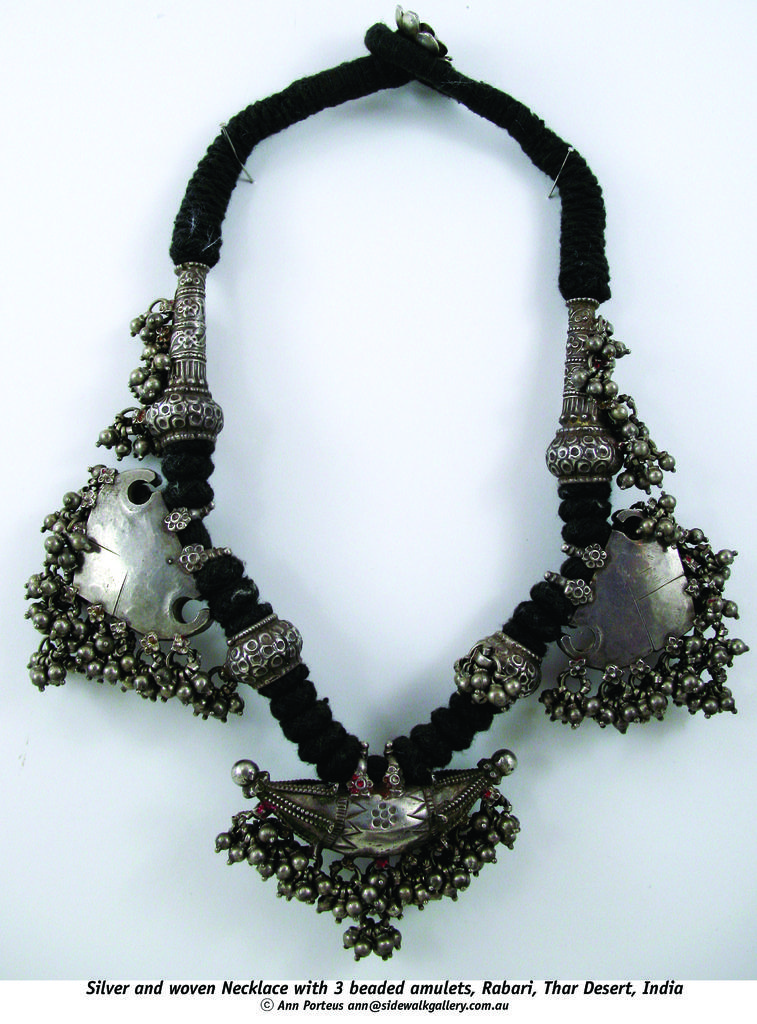What type of jewelry is present in the image? There is a necklace in the picture. What is the color of the necklace? The necklace is black in color. What words are present under the necklace in the image? There are black color words in the picture under the necklace. What is the color of the background in the image? The background of the image is white. How many boats are visible in the image? There are no boats present in the image. What is the top of the necklace made of in the image? The image does not provide information about the material or composition of the necklace's top. 